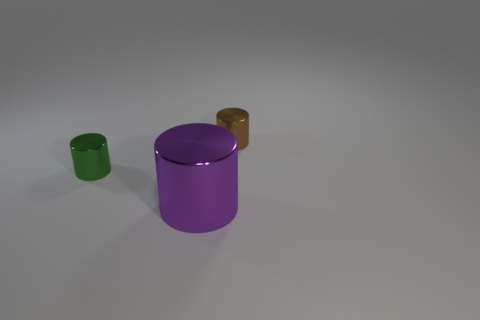There is a thing in front of the small metal cylinder left of the tiny brown thing; what number of tiny green cylinders are to the right of it? 0 